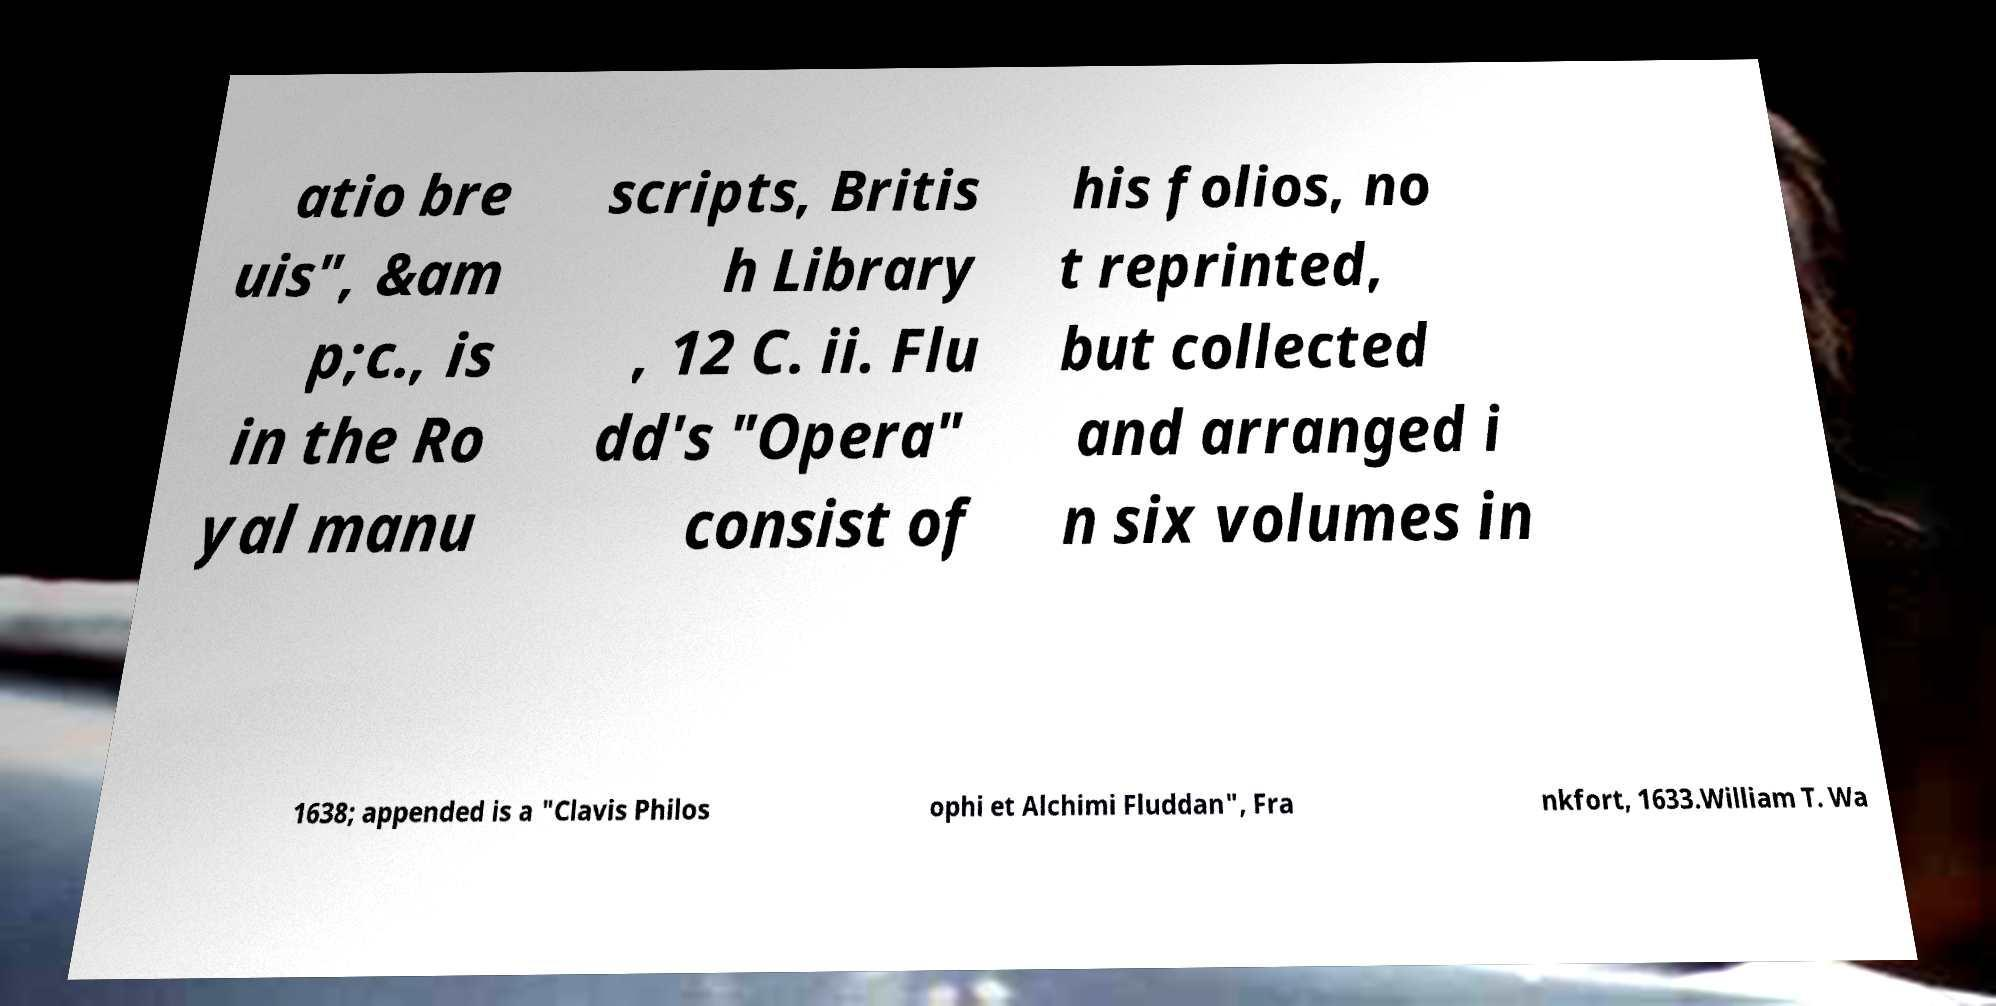There's text embedded in this image that I need extracted. Can you transcribe it verbatim? atio bre uis", &am p;c., is in the Ro yal manu scripts, Britis h Library , 12 C. ii. Flu dd's "Opera" consist of his folios, no t reprinted, but collected and arranged i n six volumes in 1638; appended is a "Clavis Philos ophi et Alchimi Fluddan", Fra nkfort, 1633.William T. Wa 